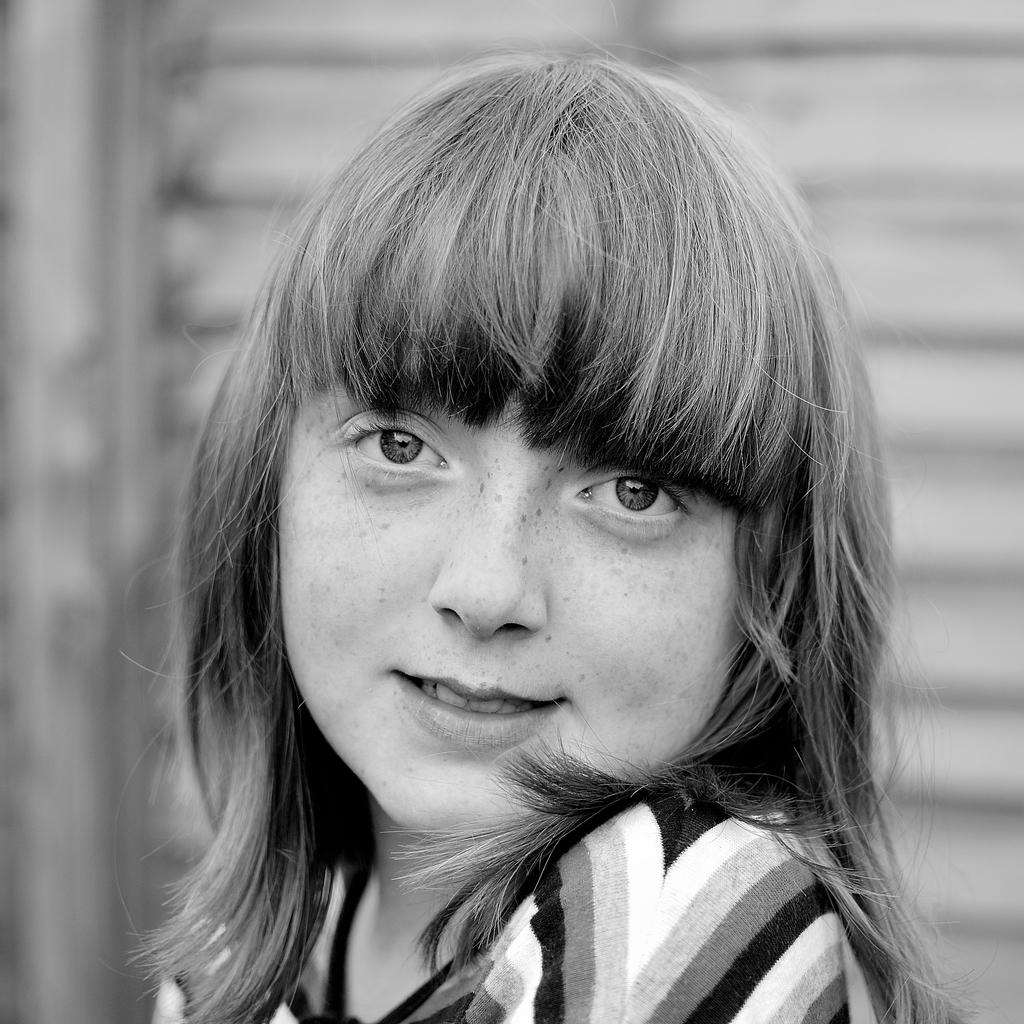Who is present in the image? There is a woman in the image. What is the woman's facial expression? The woman is smiling. Can you describe the background of the image? The background of the image is blurry. What type of juice is the woman holding in the image? There is no juice present in the image; the woman is not holding any object. 